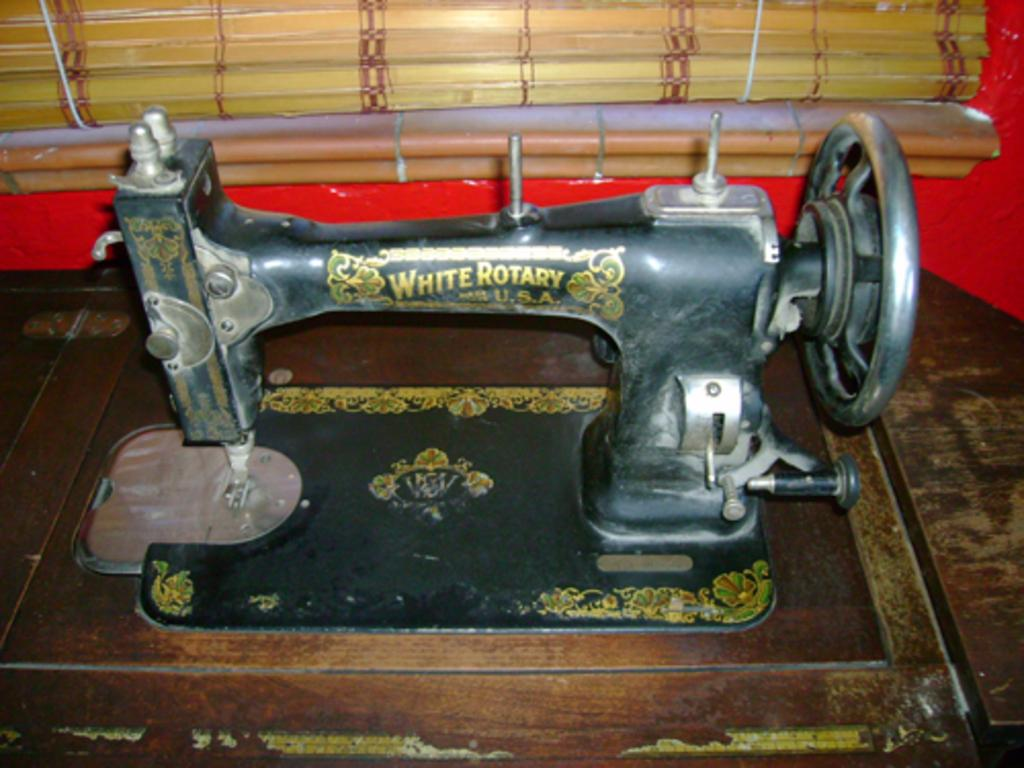What is placed on the table in the image? There is a machine placed on a table in the image. What can be seen at the top of the image? Window blinds are visible at the top of the image. Can you see a stranger riding a train on the cushion in the image? There is no train, stranger, or cushion present in the image. 